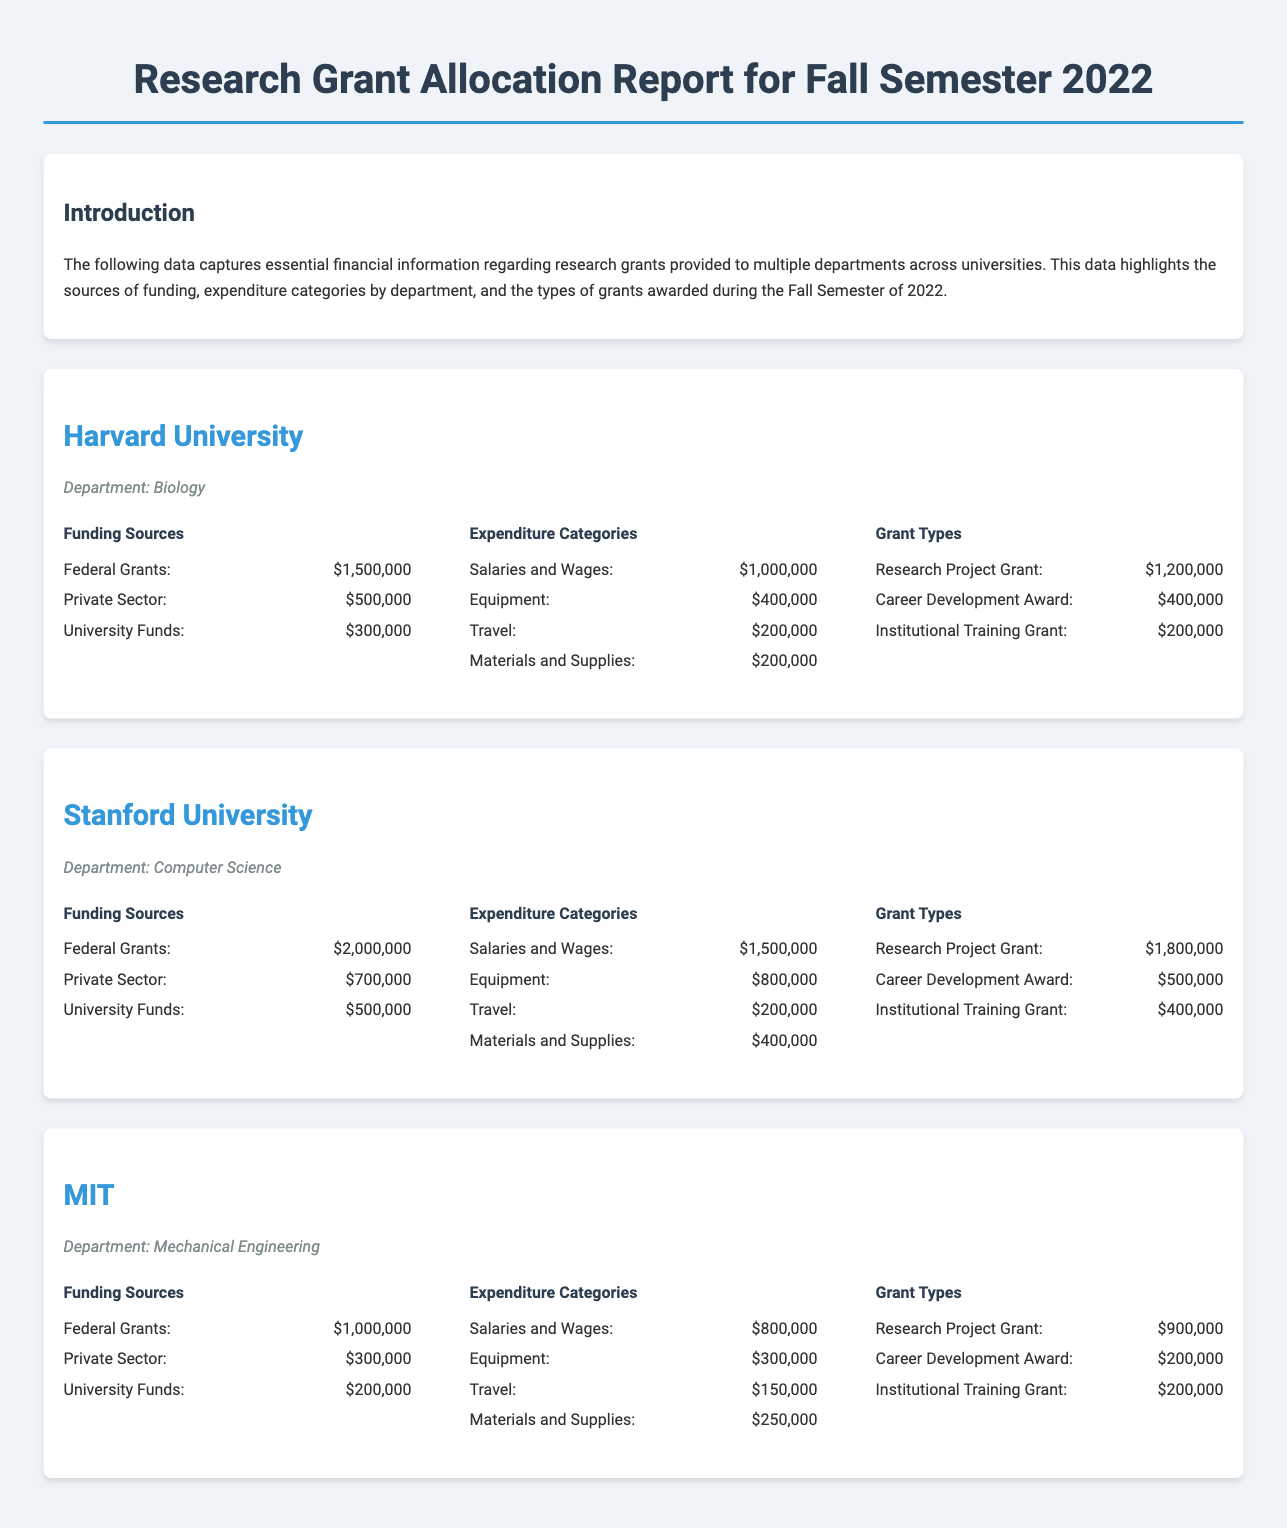What is the total funding from Federal Grants at Harvard University? The total funding from Federal Grants at Harvard University is specifically mentioned as $1,500,000 in the document.
Answer: $1,500,000 What are the total salaries and wages for the Computer Science department at Stanford University? The total salaries and wages for the Computer Science department at Stanford University are outlined as $1,500,000 in the document.
Answer: $1,500,000 Which department at MIT received the least amount of funding from Private Sector sources? MIT's Mechanical Engineering department received $300,000 from Private Sector sources, which is less compared to the other universities mentioned.
Answer: Mechanical Engineering How much was allocated for travel expenses in the Biology department at Harvard University? The travel expenses allocated in the Biology department at Harvard University is specifically stated as $200,000.
Answer: $200,000 What is the total amount for Research Project Grants across all universities listed? The total amount for Research Project Grants includes $1,200,000 from Harvard, $1,800,000 from Stanford, and $900,000 from MIT, totaling $3,900,000.
Answer: $3,900,000 Which university has the highest total funding allocation from University Funds? The total funding allocation from University Funds at Stanford University is the highest at $500,000 compared to others.
Answer: Stanford University What type of award received $200,000 in funding at MIT? The type of award that received $200,000 in funding at MIT is the Career Development Award, as stated in the document.
Answer: Career Development Award What was the total expenditure on Equipment for the Computer Science department at Stanford University? The total expenditure on Equipment for the Computer Science department at Stanford University is reported as $800,000 in the document.
Answer: $800,000 How much funding did the Institutional Training Grant receive from Harvard University? The funding allocated for the Institutional Training Grant from Harvard University is $200,000, as indicated in the document.
Answer: $200,000 